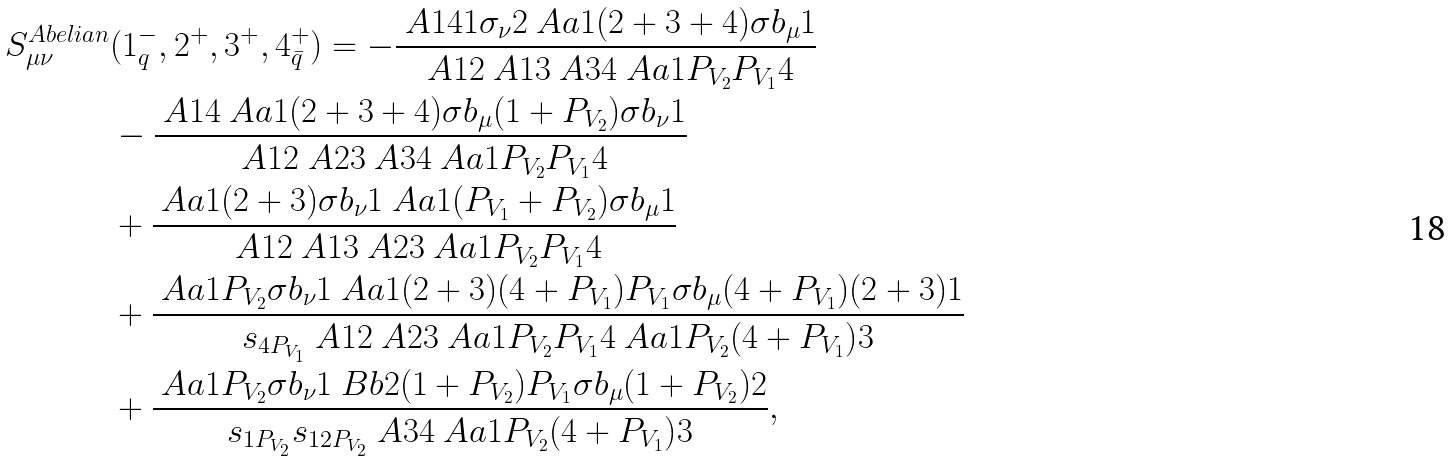<formula> <loc_0><loc_0><loc_500><loc_500>S ^ { A b e l i a n } _ { \mu \nu } & ( 1 _ { q } ^ { - } , 2 ^ { + } , 3 ^ { + } , 4 _ { \bar { q } } ^ { + } ) = - \frac { \ A { 1 } { 4 } \AA { 1 } { \sigma _ { \nu } } { 2 } \ A a { 1 } { ( 2 + 3 + 4 ) \sigma b _ { \mu } } { 1 } } { \ A { 1 } { 2 } \ A { 1 } { 3 } \ A { 3 } { 4 } \ A a { 1 } { P _ { V _ { 2 } } P _ { V _ { 1 } } } { 4 } } \\ & - \frac { \ A { 1 } { 4 } \ A a { 1 } { ( 2 + 3 + 4 ) \sigma b _ { \mu } ( 1 + P _ { V _ { 2 } } ) \sigma b _ { \nu } } { 1 } } { \ A { 1 } { 2 } \ A { 2 } { 3 } \ A { 3 } { 4 } \ A a { 1 } { P _ { V _ { 2 } } P _ { V _ { 1 } } } { 4 } } \\ & + \frac { \ A a { 1 } { ( 2 + 3 ) \sigma b _ { \nu } } { 1 } \ A a { 1 } { ( P _ { V _ { 1 } } + P _ { V _ { 2 } } ) \sigma b _ { \mu } } { 1 } } { \ A { 1 } { 2 } \ A { 1 } { 3 } \ A { 2 } { 3 } \ A a { 1 } { P _ { V _ { 2 } } P _ { V _ { 1 } } } { 4 } } \\ & + \frac { \ A a { 1 } { P _ { V _ { 2 } } \sigma b _ { \nu } } { 1 } \ A a { 1 } { ( 2 + 3 ) ( 4 + P _ { V _ { 1 } } ) P _ { V _ { 1 } } \sigma b _ { \mu } ( 4 + P _ { V _ { 1 } } ) ( 2 + 3 ) } { 1 } } { s _ { 4 P _ { V _ { 1 } } } \ A { 1 } { 2 } \ A { 2 } { 3 } \ A a { 1 } { P _ { V _ { 2 } } P _ { V _ { 1 } } } { 4 } \ A a { 1 } { P _ { V _ { 2 } } ( 4 + P _ { V _ { 1 } } ) } { 3 } } \\ & + \frac { \ A a { 1 } { P _ { V _ { 2 } } \sigma b _ { \nu } } { 1 } \ B b { 2 } { ( 1 + P _ { V _ { 2 } } ) P _ { V _ { 1 } } \sigma b _ { \mu } ( 1 + P _ { V _ { 2 } } ) } { 2 } } { s _ { 1 P _ { V _ { 2 } } } s _ { 1 2 P _ { V _ { 2 } } } \ A { 3 } { 4 } \ A a { 1 } { P _ { V _ { 2 } } ( 4 + P _ { V _ { 1 } } ) } { 3 } } ,</formula> 